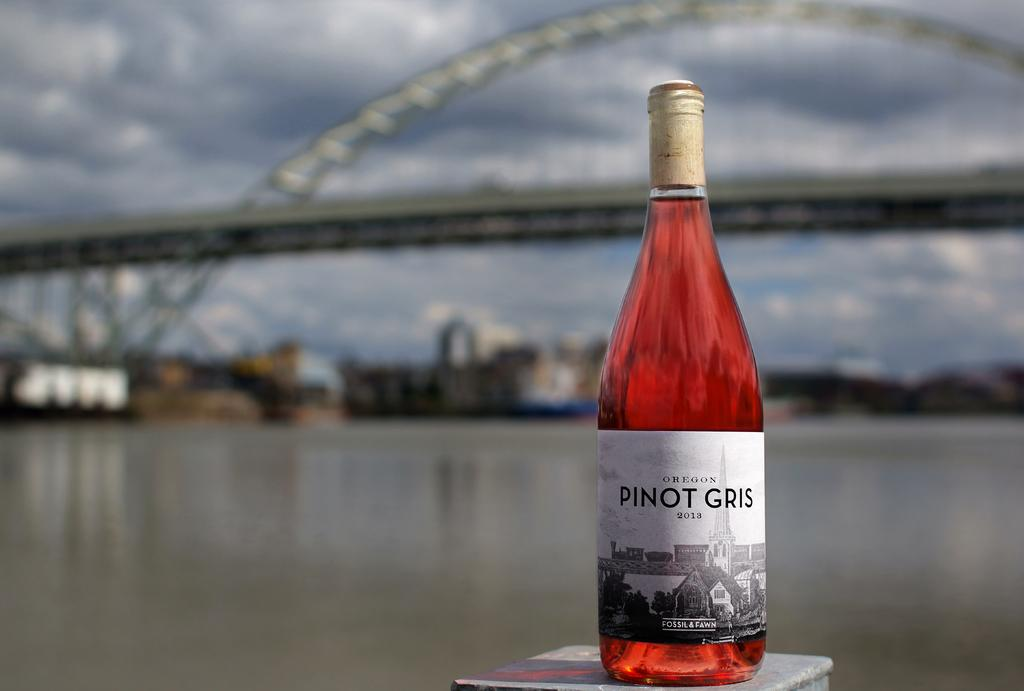<image>
Relay a brief, clear account of the picture shown. A 2013 bottle of Pinto Gris sits in front of a city skyline view. 